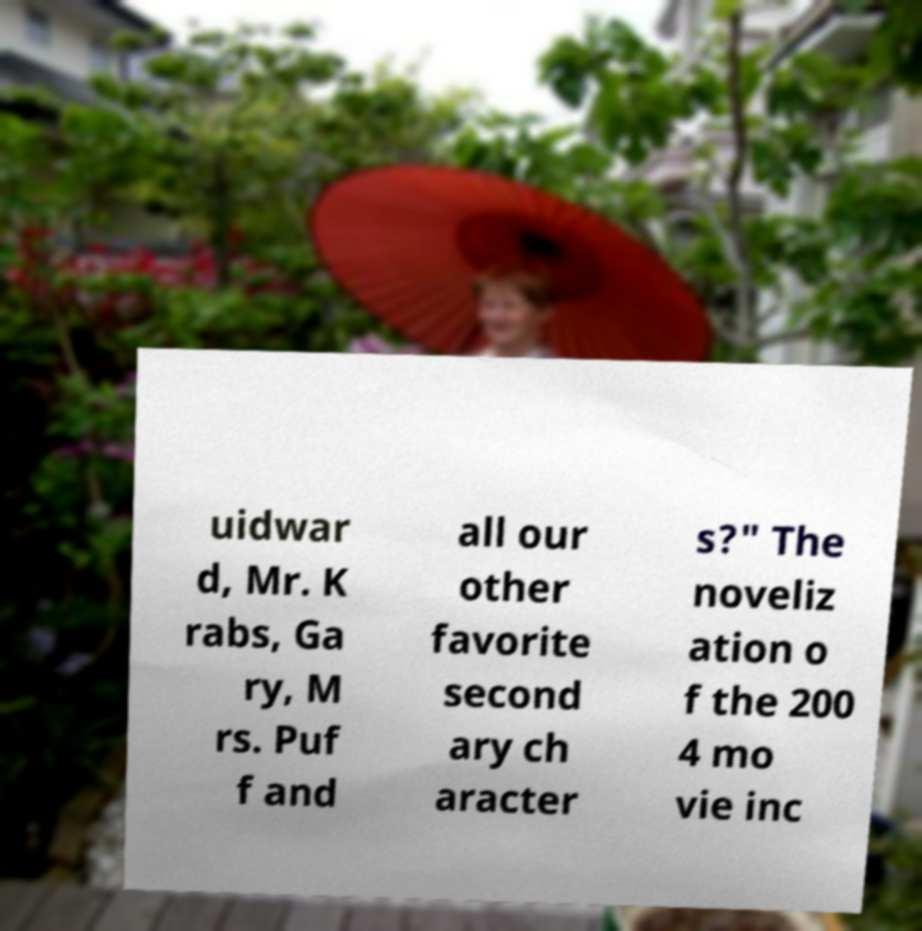Could you assist in decoding the text presented in this image and type it out clearly? uidwar d, Mr. K rabs, Ga ry, M rs. Puf f and all our other favorite second ary ch aracter s?" The noveliz ation o f the 200 4 mo vie inc 